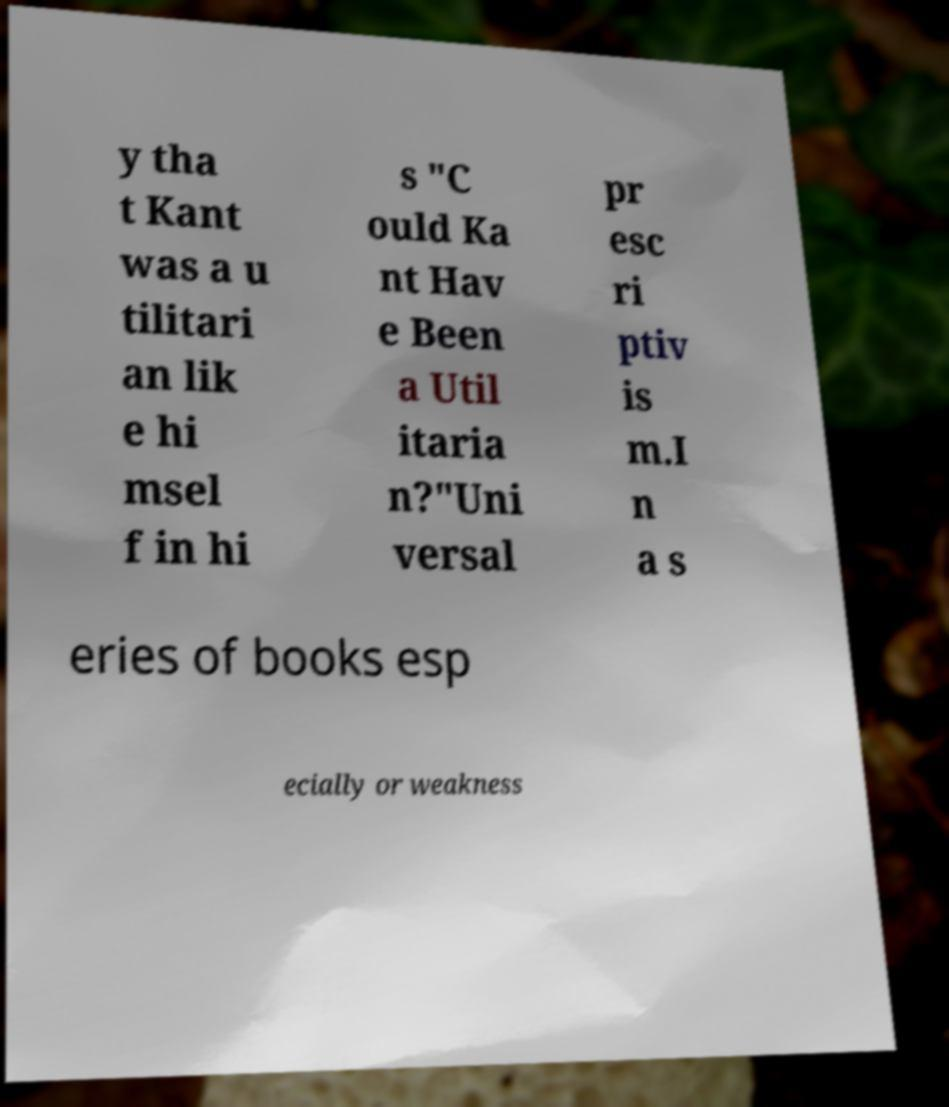Please read and relay the text visible in this image. What does it say? y tha t Kant was a u tilitari an lik e hi msel f in hi s "C ould Ka nt Hav e Been a Util itaria n?"Uni versal pr esc ri ptiv is m.I n a s eries of books esp ecially or weakness 